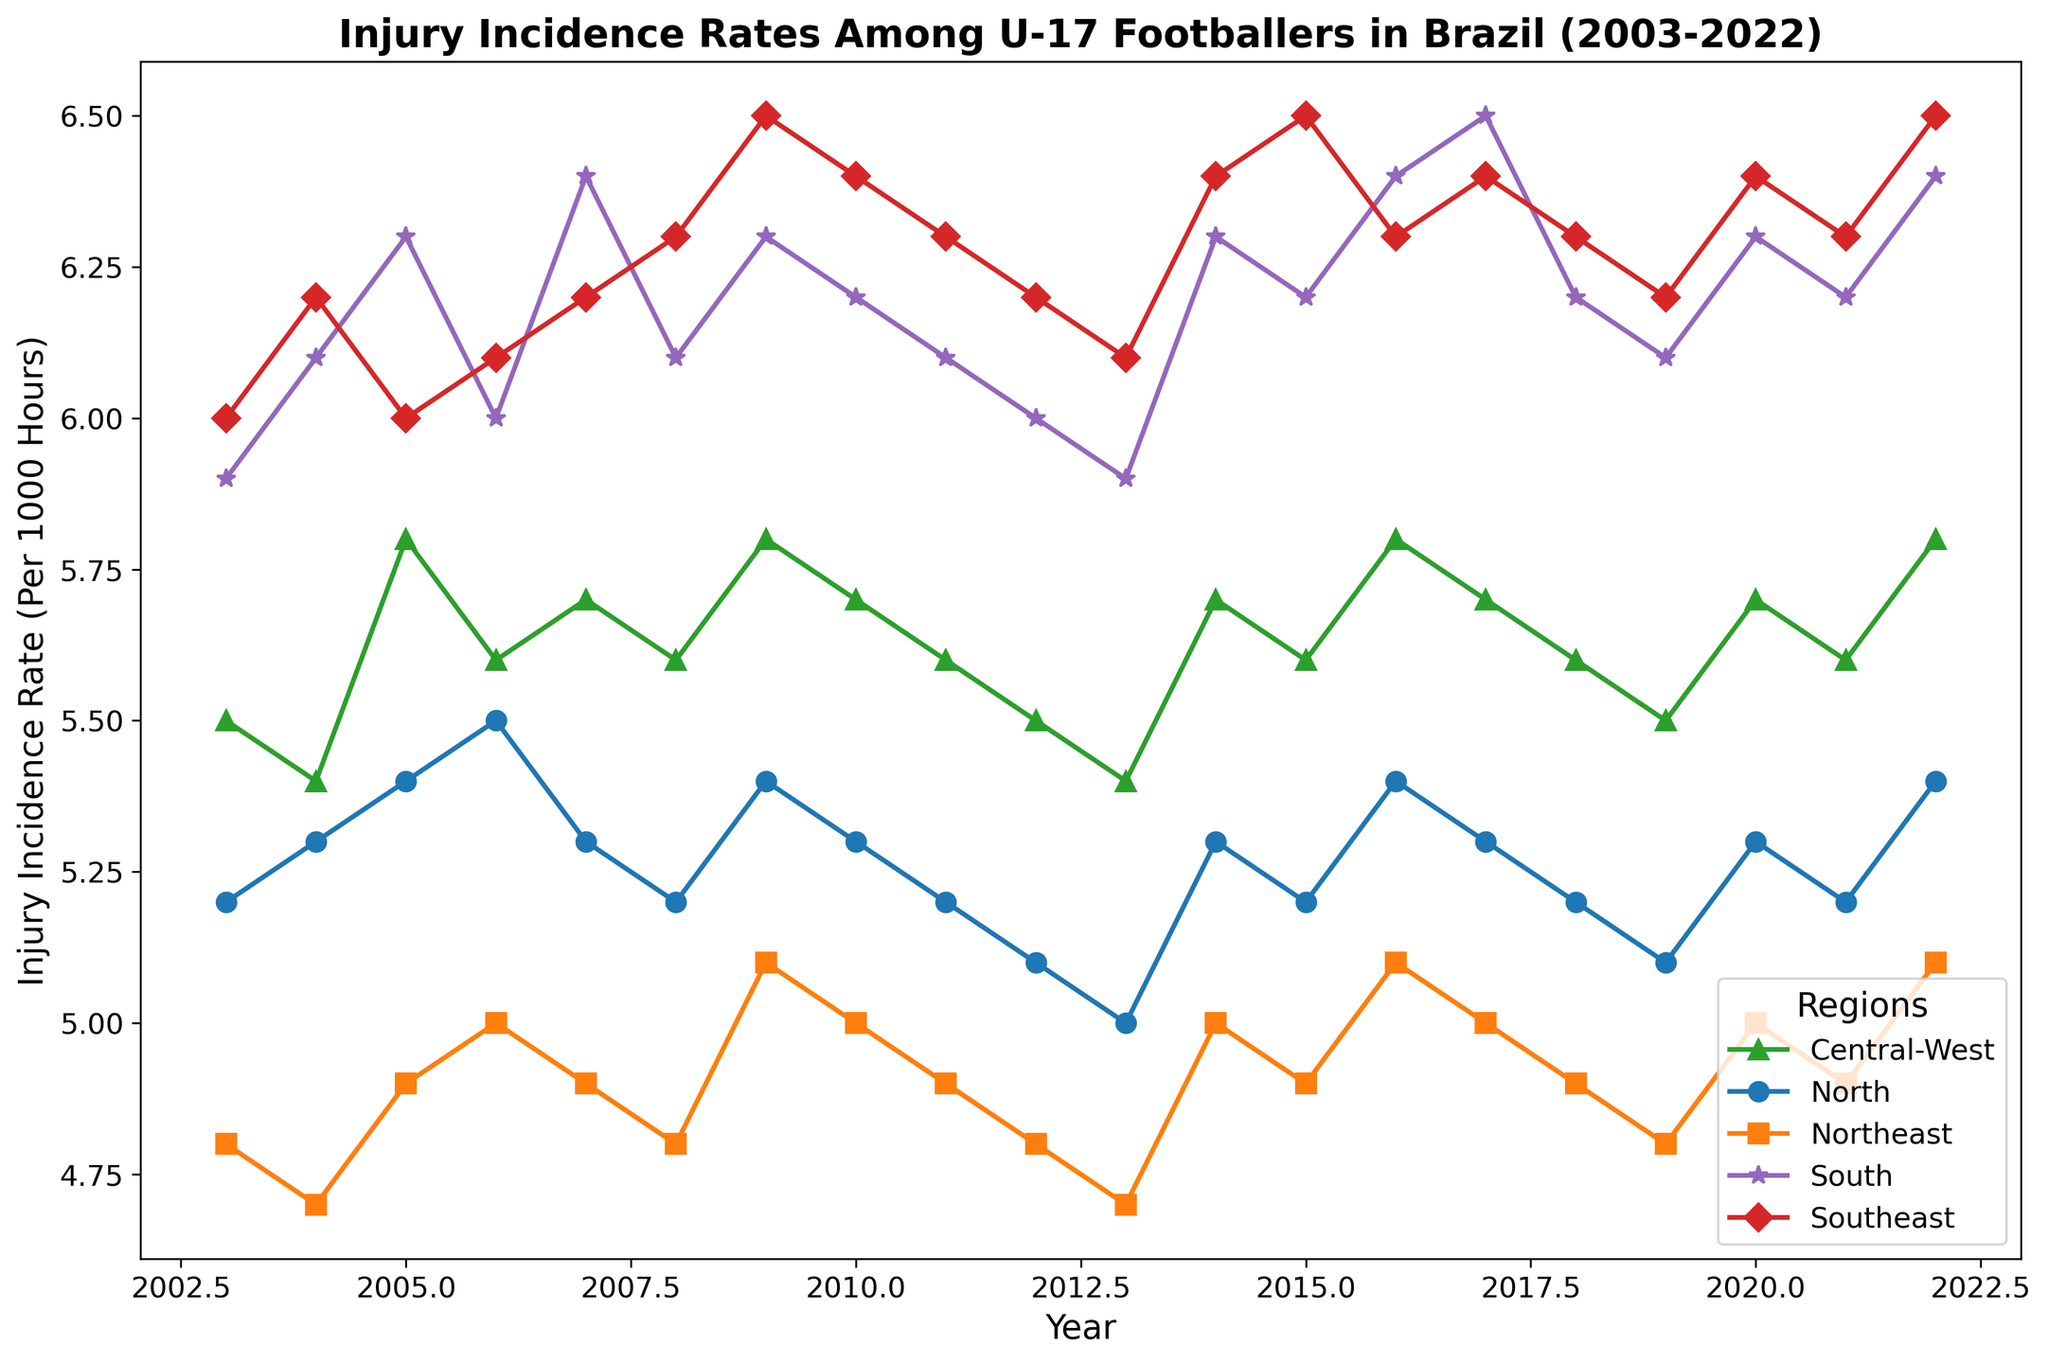Which region had the highest injury incidence rate in 2022? Look at the line plot for the year 2022 and identify the region with the highest value on the y-axis
Answer: Southeast How did the injury incidence rate for the Northeast region change from 2010 to 2011? Compare the data points for the Northeast region between the years 2010 and 2011, noting whether the value increased, decreased, or stayed the same
Answer: Decreased Which two regions had the closest injury incidence rates in the year 2015? Identify and compare the rates for all five regions in 2015, then find the two regions whose values are numerically closest on the y-axis
Answer: North and Northeast In which year did the Central-West region first surpass an incidence rate of 5.6 per 1000 hours? Analyze the plotted line for the Central-West region and note the first year where the rate is higher than 5.6
Answer: 2005 Compare the trend of injury incidence rates for the North and South regions from 2003 to 2022 Look at the plotted lines for both the North and South regions over the years and describe the general pattern or trend (e.g., increasing, decreasing, stable)
Answer: North: slight fluctuations, mostly stable around 5.2-5.4. South: generally stable around 6.0-6.4 Between which two consecutive years did the South region see the largest increase in injury incidence rate? Observe the plotted line for the South region and determine the two consecutive years with the largest positive change in rate value
Answer: 2006 to 2007 Which region showed the lowest injury incidence rate in 2013? Identify the region with the lowest value on the y-axis for the year 2013
Answer: Northeast What was the overall trend in injury incidence rates for the Southeast region from 2003 to 2022? Follow the plotted line for the Southeast region from start to end and describe the overall pattern (e.g., increasing, decreasing, fluctuating)
Answer: Generally fluctuating with an upward trend 